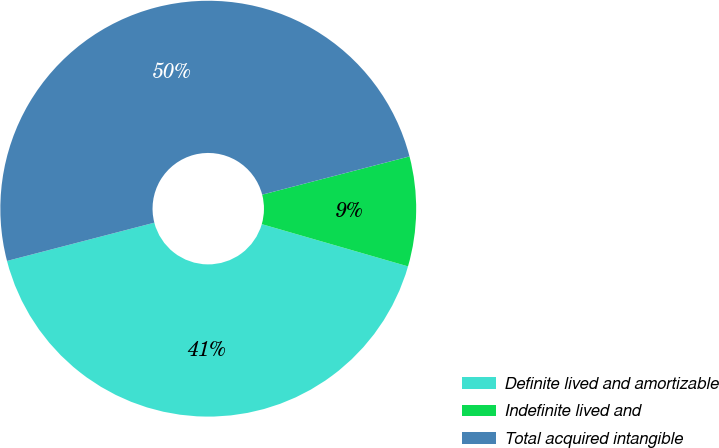Convert chart. <chart><loc_0><loc_0><loc_500><loc_500><pie_chart><fcel>Definite lived and amortizable<fcel>Indefinite lived and<fcel>Total acquired intangible<nl><fcel>41.48%<fcel>8.52%<fcel>50.0%<nl></chart> 